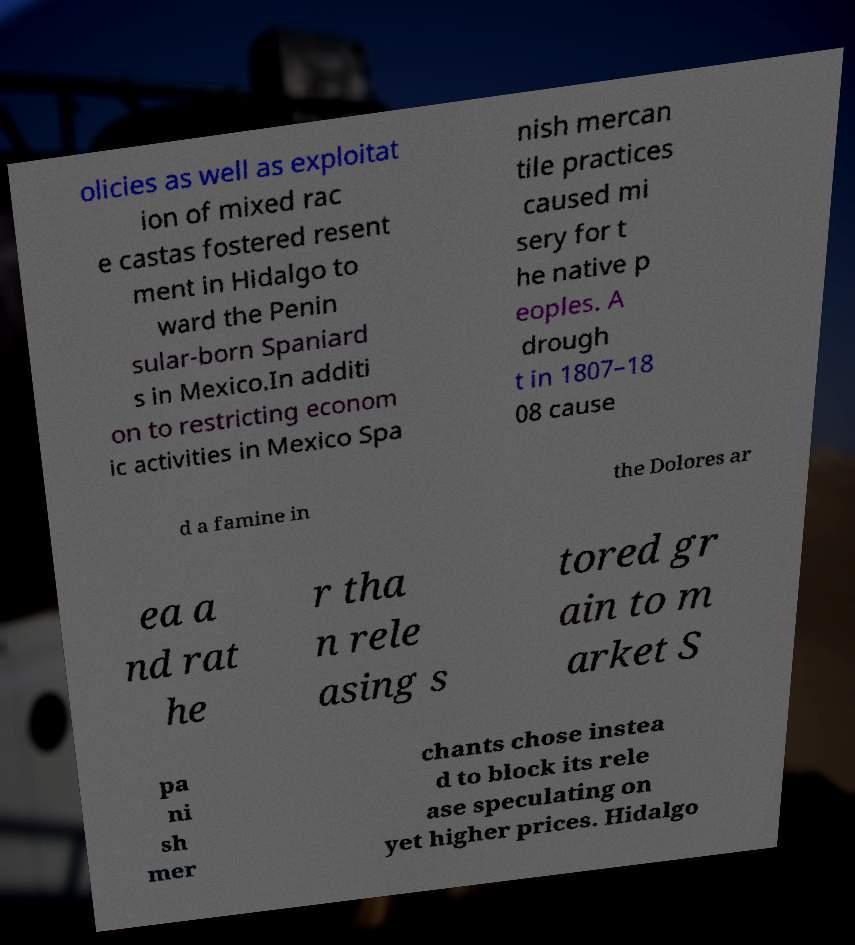What messages or text are displayed in this image? I need them in a readable, typed format. olicies as well as exploitat ion of mixed rac e castas fostered resent ment in Hidalgo to ward the Penin sular-born Spaniard s in Mexico.In additi on to restricting econom ic activities in Mexico Spa nish mercan tile practices caused mi sery for t he native p eoples. A drough t in 1807–18 08 cause d a famine in the Dolores ar ea a nd rat he r tha n rele asing s tored gr ain to m arket S pa ni sh mer chants chose instea d to block its rele ase speculating on yet higher prices. Hidalgo 